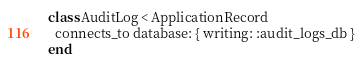Convert code to text. <code><loc_0><loc_0><loc_500><loc_500><_Ruby_>class AuditLog < ApplicationRecord
  connects_to database: { writing: :audit_logs_db }
end
</code> 